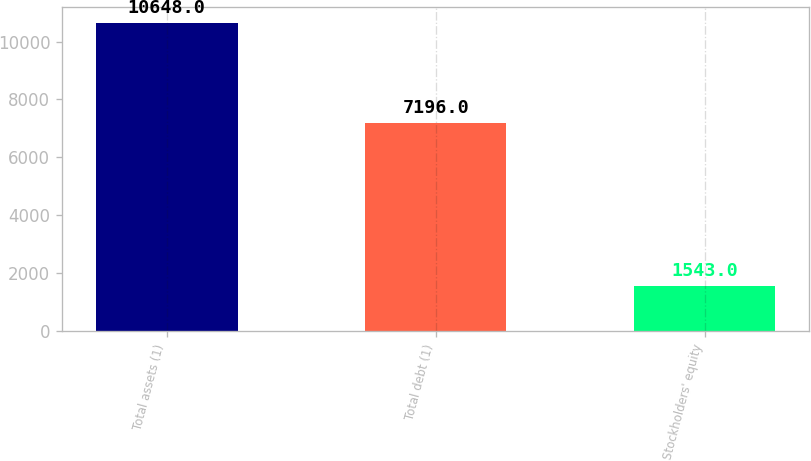Convert chart to OTSL. <chart><loc_0><loc_0><loc_500><loc_500><bar_chart><fcel>Total assets (1)<fcel>Total debt (1)<fcel>Stockholders' equity<nl><fcel>10648<fcel>7196<fcel>1543<nl></chart> 